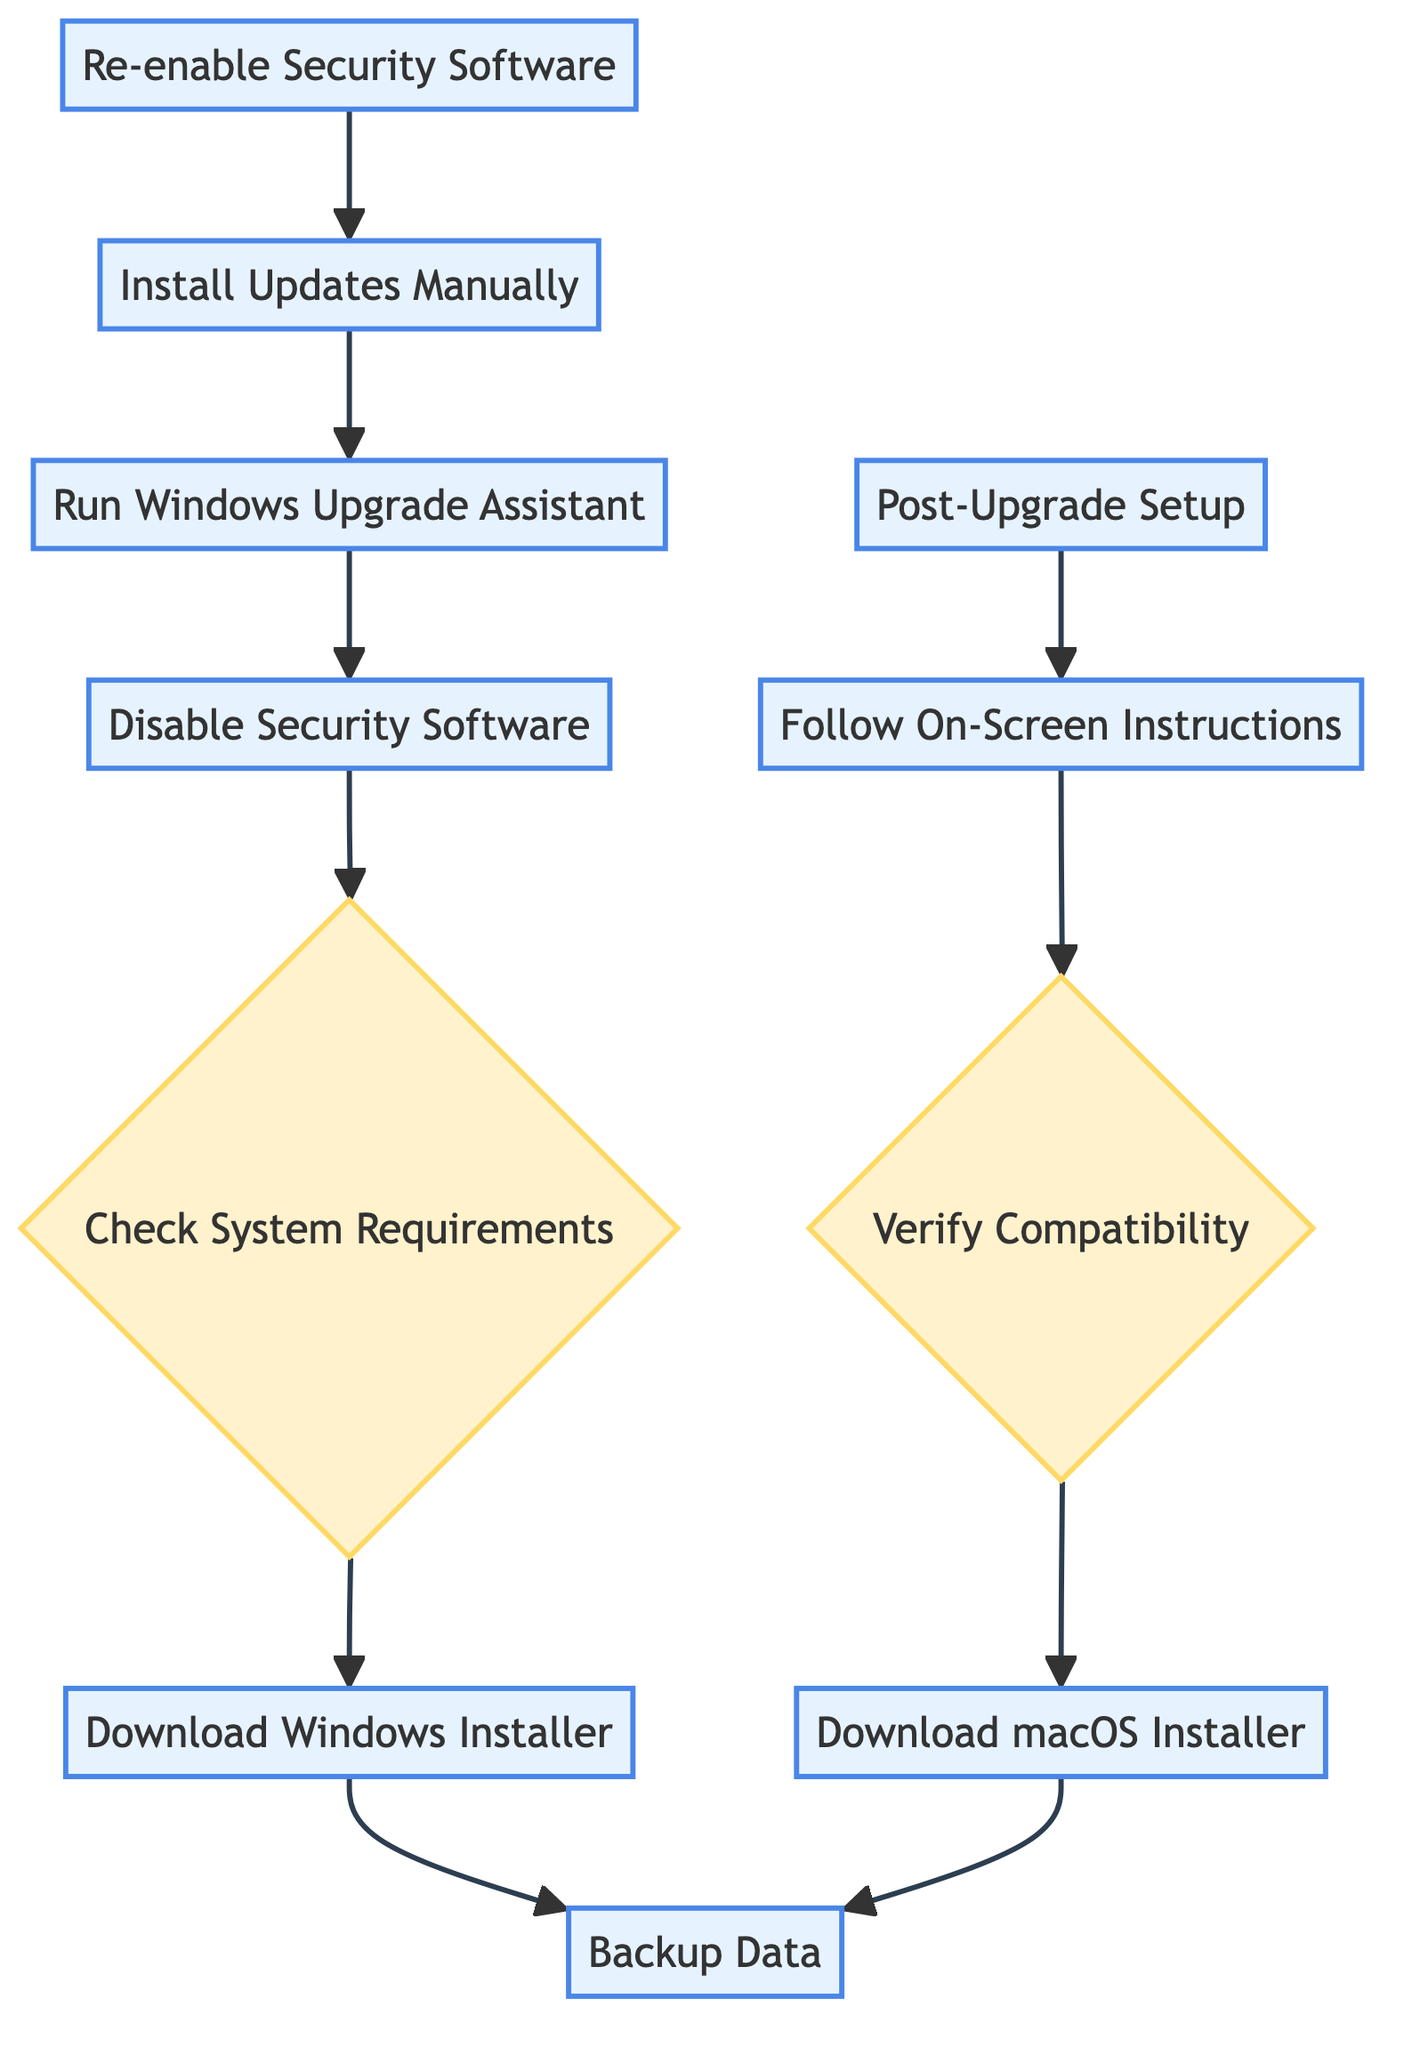What is the first step in upgrading macOS? The first step in upgrading macOS is to "Backup Data" which is the initial process node at the bottom of the diagram.
Answer: Backup Data How many decision nodes are present in the diagram? There are two decision nodes in the diagram: "Verify Compatibility" for macOS and "Check System Requirements" for Windows.
Answer: 2 Which task follows "Run Windows Upgrade Assistant"? The task that follows "Run Windows Upgrade Assistant" is "Install Updates Manually". This can be seen as the flow moves upwards from the Windows Upgrade Assistant node.
Answer: Install Updates Manually What is the last process step in upgrading Windows? The last process step in upgrading Windows is "Re-enable Security Software", located at the bottom of the Windows upgrade sequence.
Answer: Re-enable Security Software What step must be taken before downloading the macOS installer? Before downloading the macOS installer, you must verify compatibility with the latest version, indicated as the decision node that comes after the download process.
Answer: Verify Compatibility Which procedure requires checking for compatibility issues in both upgrades? Both upgrades require checking for compatibility issues; for macOS it is "Verify Compatibility" and for Windows it is "Check System Requirements". Thus, they both follow after their respective download steps.
Answer: Verify Compatibility and Check System Requirements What task must be done just before post-upgrade setup for macOS? You must "Follow On-Screen Instructions" just before proceeding to the "Post-Upgrade Setup" in the macOS upgrade process, as shown by the upward flow between those nodes.
Answer: Follow On-Screen Instructions How many total process steps are there in upgrading Windows? There are five process steps in upgrading Windows, which are "Download Windows Installer", "Disable Security Software", "Run Windows Upgrade Assistant", "Install Updates Manually", and "Re-enable Security Software".
Answer: 5 Which section of the diagram indicates the need for backups before the upgrade process? The section of the diagram indicating the need for backups is at the very beginning with the "Backup Data" process step shown at the bottom and leading into the upgrade processes.
Answer: Backup Data 